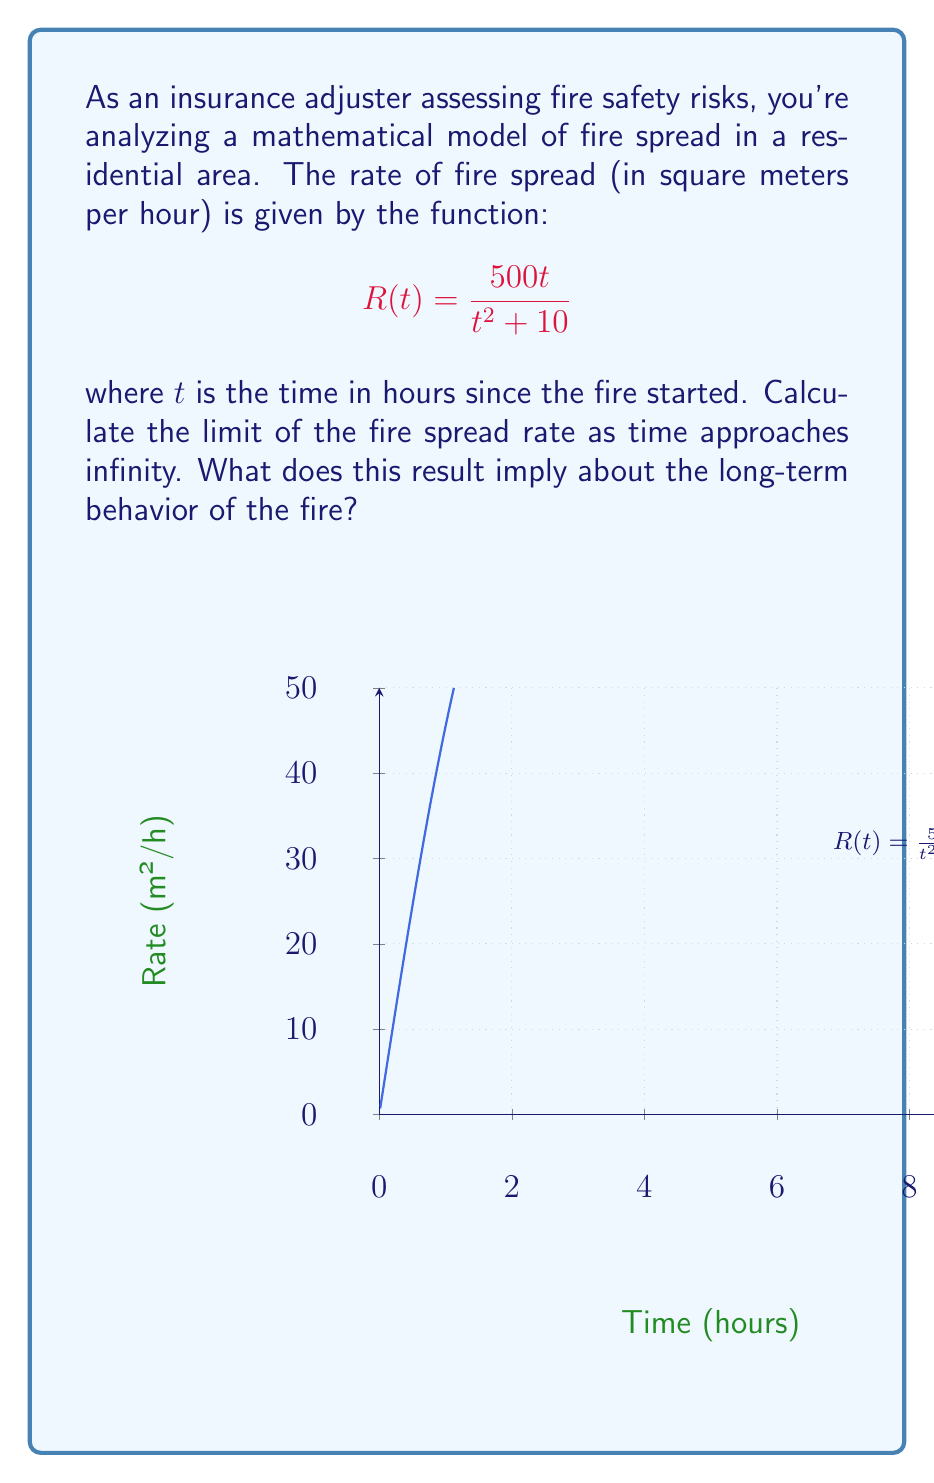Solve this math problem. To find the limit of the fire spread rate as time approaches infinity, we need to evaluate:

$$\lim_{t \to \infty} R(t) = \lim_{t \to \infty} \frac{500t}{t^2 + 10}$$

Let's approach this step-by-step:

1) First, we can factor out $t^2$ from the denominator:

   $$\lim_{t \to \infty} \frac{500t}{t^2 + 10} = \lim_{t \to \infty} \frac{500t}{t^2(1 + \frac{10}{t^2})}$$

2) Now, we can separate this fraction:

   $$\lim_{t \to \infty} \frac{500}{t} \cdot \frac{1}{1 + \frac{10}{t^2}}$$

3) As $t$ approaches infinity, $\frac{10}{t^2}$ approaches 0, so:

   $$\lim_{t \to \infty} \frac{500}{t} \cdot \frac{1}{1 + 0} = \lim_{t \to \infty} \frac{500}{t}$$

4) Finally, as $t$ approaches infinity, $\frac{500}{t}$ approaches 0.

Therefore, the limit of the fire spread rate as time approaches infinity is 0.

This result implies that in the long term, the fire spread rate decreases to zero, meaning the fire's expansion slows down and eventually stops spreading further.
Answer: $\lim_{t \to \infty} R(t) = 0$ m²/h 